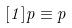<formula> <loc_0><loc_0><loc_500><loc_500>[ 1 ] p \equiv p</formula> 